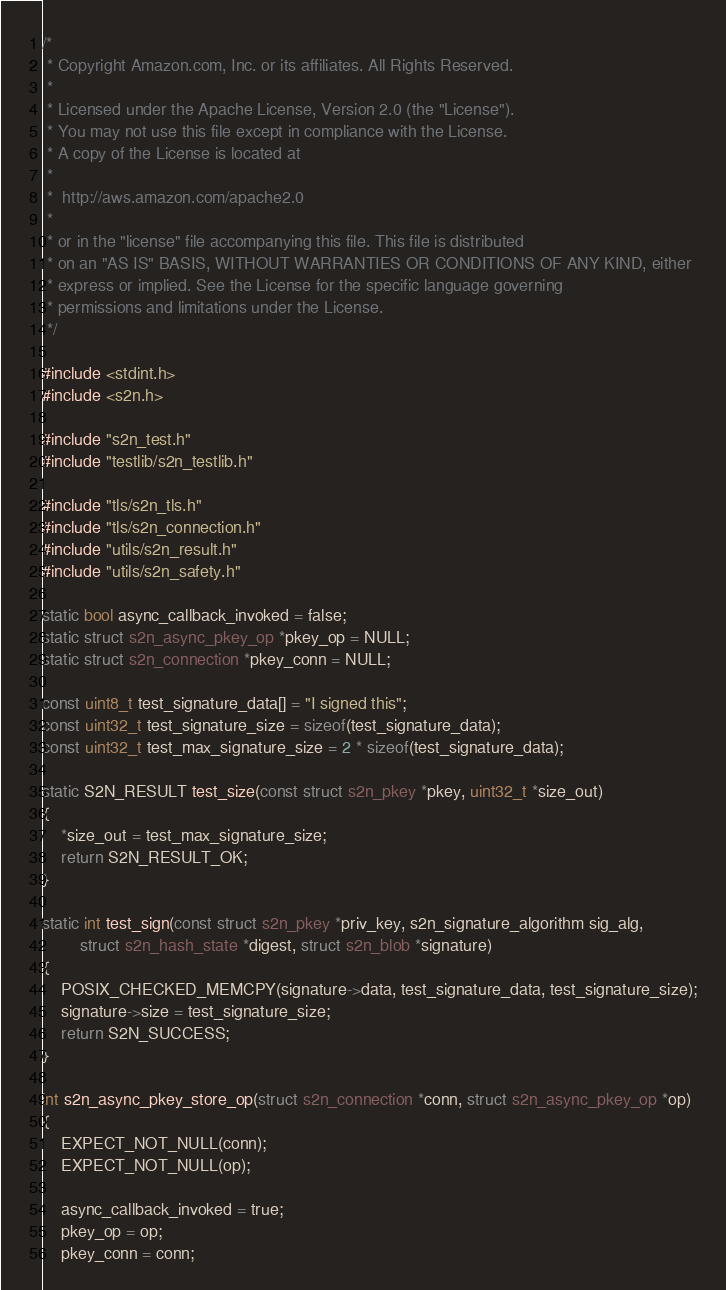Convert code to text. <code><loc_0><loc_0><loc_500><loc_500><_C_>/*
 * Copyright Amazon.com, Inc. or its affiliates. All Rights Reserved.
 *
 * Licensed under the Apache License, Version 2.0 (the "License").
 * You may not use this file except in compliance with the License.
 * A copy of the License is located at
 *
 *  http://aws.amazon.com/apache2.0
 *
 * or in the "license" file accompanying this file. This file is distributed
 * on an "AS IS" BASIS, WITHOUT WARRANTIES OR CONDITIONS OF ANY KIND, either
 * express or implied. See the License for the specific language governing
 * permissions and limitations under the License.
 */

#include <stdint.h>
#include <s2n.h>

#include "s2n_test.h"
#include "testlib/s2n_testlib.h"

#include "tls/s2n_tls.h"
#include "tls/s2n_connection.h"
#include "utils/s2n_result.h"
#include "utils/s2n_safety.h"

static bool async_callback_invoked = false;
static struct s2n_async_pkey_op *pkey_op = NULL;
static struct s2n_connection *pkey_conn = NULL;

const uint8_t test_signature_data[] = "I signed this";
const uint32_t test_signature_size = sizeof(test_signature_data);
const uint32_t test_max_signature_size = 2 * sizeof(test_signature_data);

static S2N_RESULT test_size(const struct s2n_pkey *pkey, uint32_t *size_out)
{
    *size_out = test_max_signature_size;
    return S2N_RESULT_OK;
}

static int test_sign(const struct s2n_pkey *priv_key, s2n_signature_algorithm sig_alg,
        struct s2n_hash_state *digest, struct s2n_blob *signature)
{
    POSIX_CHECKED_MEMCPY(signature->data, test_signature_data, test_signature_size);
    signature->size = test_signature_size;
    return S2N_SUCCESS;
}

int s2n_async_pkey_store_op(struct s2n_connection *conn, struct s2n_async_pkey_op *op)
{
    EXPECT_NOT_NULL(conn);
    EXPECT_NOT_NULL(op);

    async_callback_invoked = true;
    pkey_op = op;
    pkey_conn = conn;
</code> 